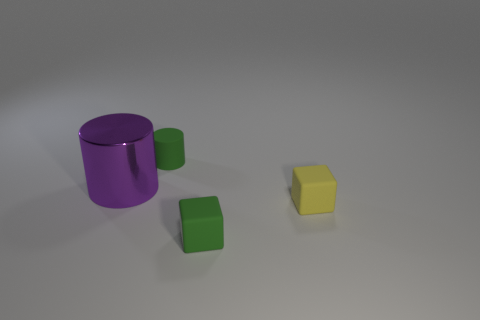There is a green matte object that is left of the tiny rubber thing in front of the small yellow rubber cube; what is its size?
Ensure brevity in your answer.  Small. Are there any other things that have the same material as the small green cube?
Your answer should be very brief. Yes. Are there more small rubber cubes than cyan spheres?
Your answer should be compact. Yes. Do the block on the right side of the tiny green block and the tiny thing left of the tiny green block have the same color?
Provide a succinct answer. No. Is there a tiny green rubber object that is to the left of the small matte thing behind the big metallic cylinder?
Offer a very short reply. No. Are there fewer green cubes behind the green cube than matte things to the left of the purple thing?
Offer a terse response. No. Is the thing that is behind the large thing made of the same material as the cube behind the green rubber cube?
Offer a terse response. Yes. What number of tiny objects are either purple shiny cylinders or blue metal cylinders?
Give a very brief answer. 0. There is a green object that is made of the same material as the green cylinder; what is its shape?
Ensure brevity in your answer.  Cube. Are there fewer big purple things that are behind the large shiny cylinder than green matte things?
Give a very brief answer. Yes. 